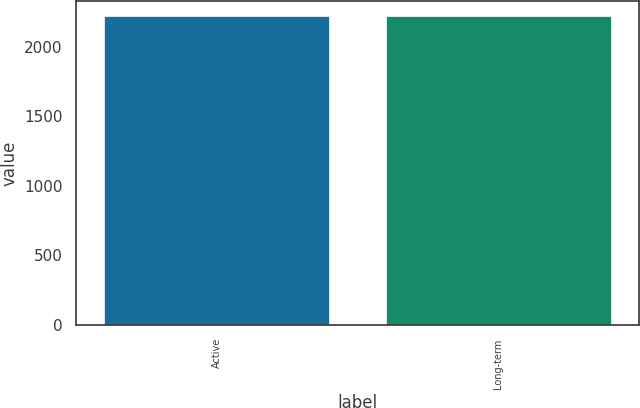Convert chart to OTSL. <chart><loc_0><loc_0><loc_500><loc_500><bar_chart><fcel>Active<fcel>Long-term<nl><fcel>2219<fcel>2219.1<nl></chart> 